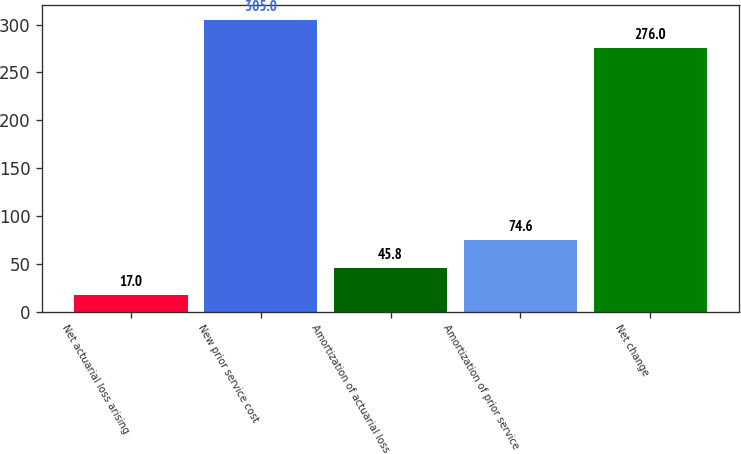Convert chart. <chart><loc_0><loc_0><loc_500><loc_500><bar_chart><fcel>Net actuarial loss arising<fcel>New prior service cost<fcel>Amortization of actuarial loss<fcel>Amortization of prior service<fcel>Net change<nl><fcel>17<fcel>305<fcel>45.8<fcel>74.6<fcel>276<nl></chart> 